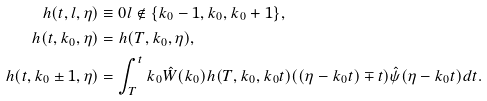<formula> <loc_0><loc_0><loc_500><loc_500>h ( t , l , \eta ) & \equiv 0 l \not \in \{ k _ { 0 } - 1 , k _ { 0 } , k _ { 0 } + 1 \} , \\ h ( t , k _ { 0 } , \eta ) & = h ( T , k _ { 0 } , \eta ) , \\ h ( t , k _ { 0 } \pm 1 , \eta ) & = \int _ { T } ^ { t } k _ { 0 } \hat { W } ( k _ { 0 } ) h ( T , k _ { 0 } , k _ { 0 } t ) ( ( \eta - k _ { 0 } t ) \mp t ) \hat { \psi } ( \eta - k _ { 0 } t ) d t .</formula> 